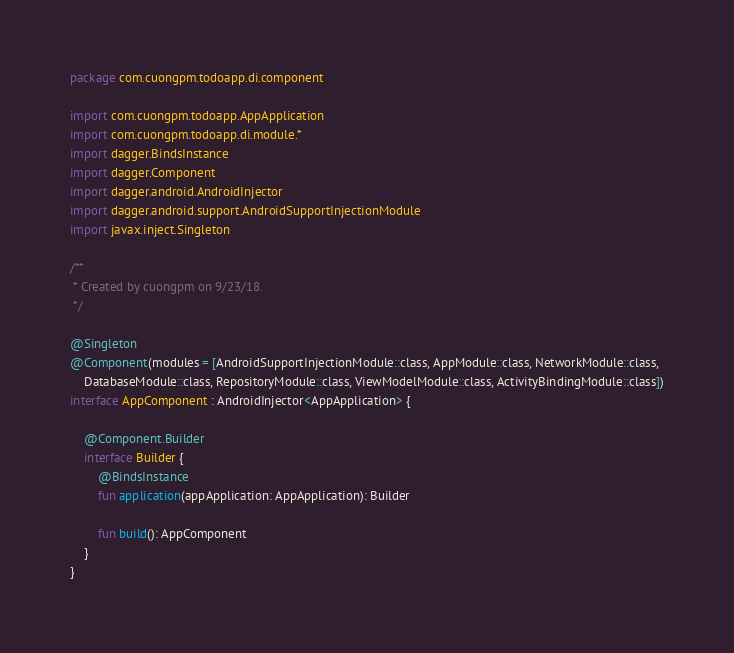Convert code to text. <code><loc_0><loc_0><loc_500><loc_500><_Kotlin_>package com.cuongpm.todoapp.di.component

import com.cuongpm.todoapp.AppApplication
import com.cuongpm.todoapp.di.module.*
import dagger.BindsInstance
import dagger.Component
import dagger.android.AndroidInjector
import dagger.android.support.AndroidSupportInjectionModule
import javax.inject.Singleton

/**
 * Created by cuongpm on 9/23/18.
 */

@Singleton
@Component(modules = [AndroidSupportInjectionModule::class, AppModule::class, NetworkModule::class,
    DatabaseModule::class, RepositoryModule::class, ViewModelModule::class, ActivityBindingModule::class])
interface AppComponent : AndroidInjector<AppApplication> {

    @Component.Builder
    interface Builder {
        @BindsInstance
        fun application(appApplication: AppApplication): Builder

        fun build(): AppComponent
    }
}</code> 